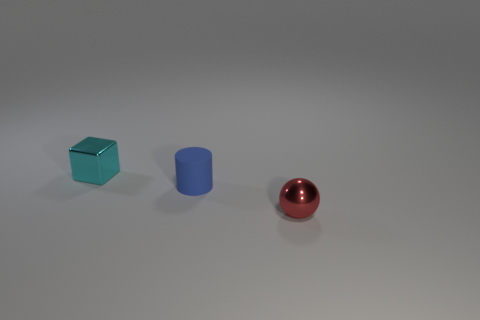There is a thing that is both to the left of the small ball and in front of the cube; what size is it?
Your response must be concise. Small. Is the material of the cyan object that is behind the tiny cylinder the same as the red thing?
Provide a succinct answer. Yes. Is there any other thing that has the same size as the blue object?
Offer a very short reply. Yes. Is the number of red spheres behind the small blue rubber cylinder less than the number of small blue rubber cylinders that are left of the shiny sphere?
Make the answer very short. Yes. There is a shiny object behind the metallic object that is in front of the blue cylinder; what number of tiny rubber objects are behind it?
Provide a short and direct response. 0. There is a small metallic block; what number of tiny red metallic objects are on the right side of it?
Offer a very short reply. 1. How many tiny cylinders have the same material as the cyan block?
Your response must be concise. 0. The other small thing that is made of the same material as the small cyan object is what color?
Your answer should be compact. Red. There is a shiny thing behind the red metallic sphere; does it have the same size as the blue cylinder?
Offer a terse response. Yes. What number of big objects are blue matte cylinders or red objects?
Your response must be concise. 0. 